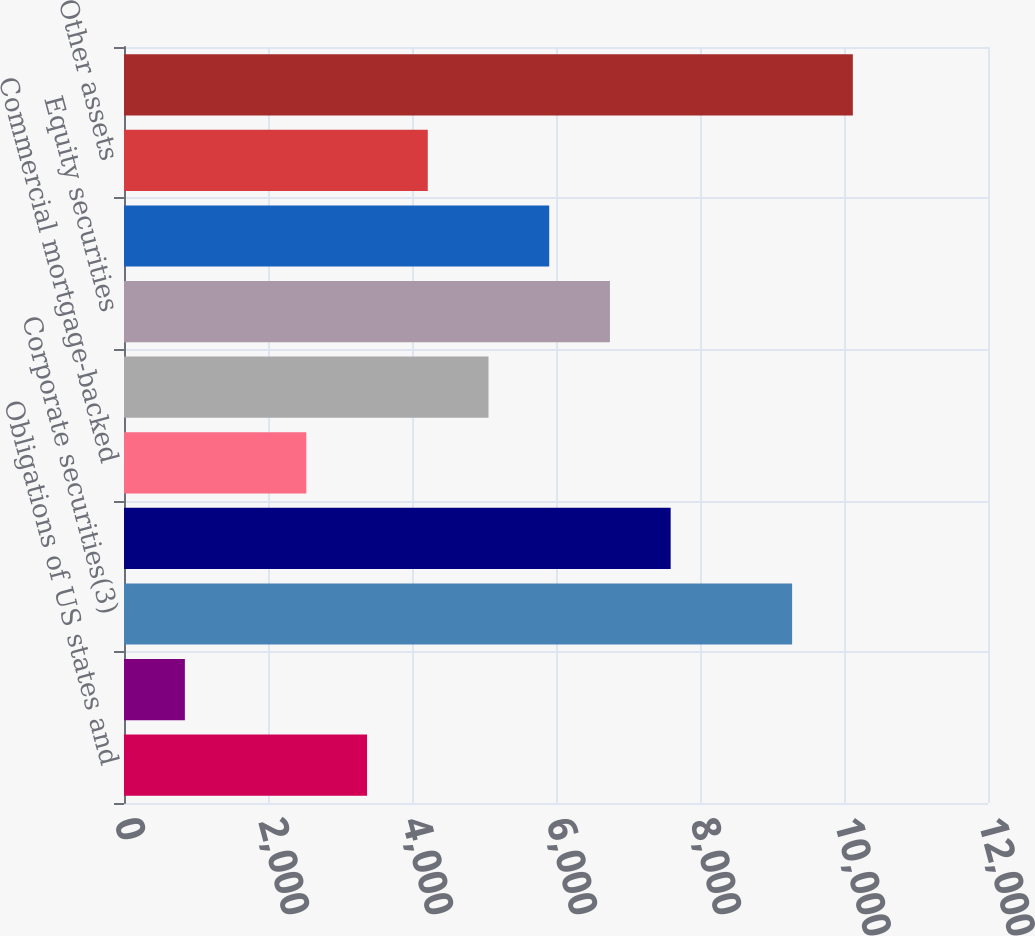Convert chart to OTSL. <chart><loc_0><loc_0><loc_500><loc_500><bar_chart><fcel>Obligations of US states and<fcel>Foreign government bonds<fcel>Corporate securities(3)<fcel>Asset-backed securities(4)<fcel>Commercial mortgage-backed<fcel>Residential mortgage-backed<fcel>Equity securities<fcel>Other long-term investments(5)<fcel>Other assets<fcel>Subtotal excluding separate<nl><fcel>3375.6<fcel>845.4<fcel>9279.4<fcel>7592.6<fcel>2532.2<fcel>5062.4<fcel>6749.2<fcel>5905.8<fcel>4219<fcel>10122.8<nl></chart> 